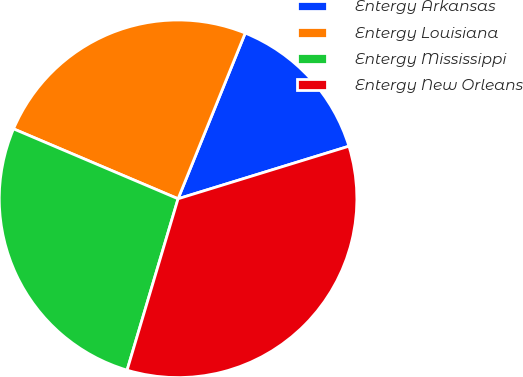Convert chart. <chart><loc_0><loc_0><loc_500><loc_500><pie_chart><fcel>Entergy Arkansas<fcel>Entergy Louisiana<fcel>Entergy Mississippi<fcel>Entergy New Orleans<nl><fcel>14.12%<fcel>24.73%<fcel>26.79%<fcel>34.35%<nl></chart> 